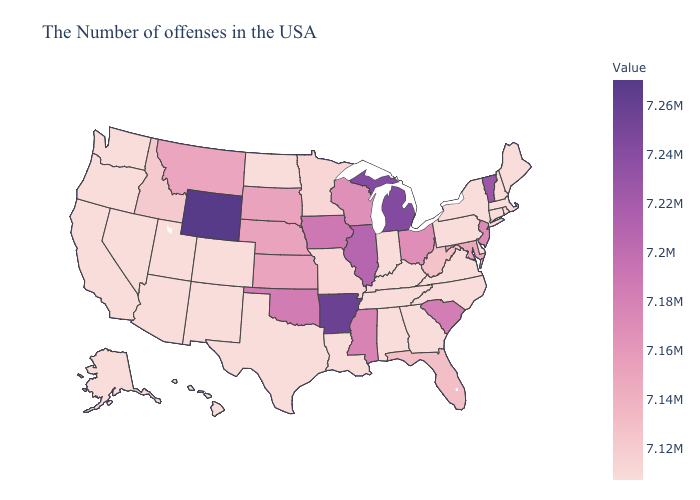Among the states that border Wisconsin , does Minnesota have the highest value?
Concise answer only. No. Does North Dakota have the lowest value in the USA?
Short answer required. Yes. Among the states that border Oklahoma , which have the highest value?
Write a very short answer. Arkansas. 